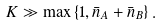Convert formula to latex. <formula><loc_0><loc_0><loc_500><loc_500>K \gg \max \left \{ 1 , \bar { n } _ { A } + \bar { n } _ { B } \right \} .</formula> 